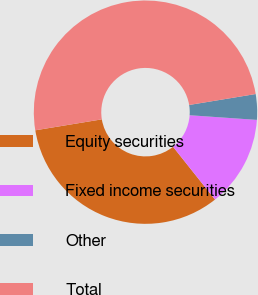Convert chart to OTSL. <chart><loc_0><loc_0><loc_500><loc_500><pie_chart><fcel>Equity securities<fcel>Fixed income securities<fcel>Other<fcel>Total<nl><fcel>33.1%<fcel>13.2%<fcel>3.7%<fcel>50.0%<nl></chart> 